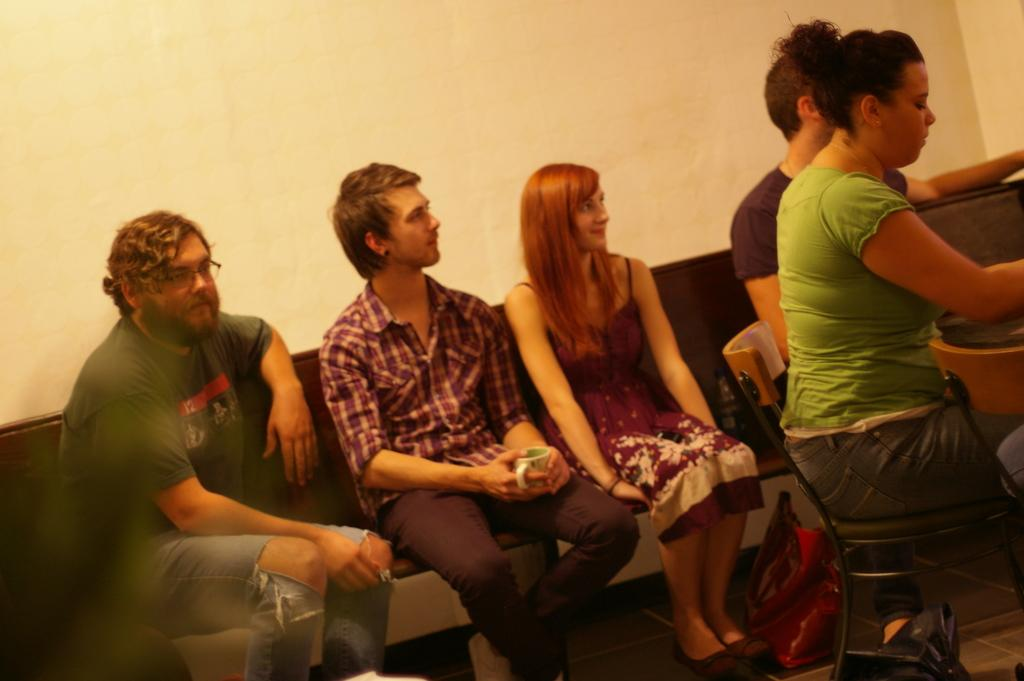Who or what can be seen in the image? There are people in the image. What are the people doing in the image? The people are sitting. Can you describe any objects in the image? There is a bag at the bottom of the image. What is the rate at which the pig is moving in the image? There is no pig present in the image, so it is not possible to determine its movement or rate. 